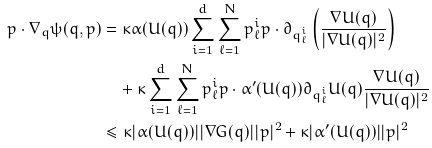Convert formula to latex. <formula><loc_0><loc_0><loc_500><loc_500>p \cdot \nabla _ { q } \psi ( q , p ) & = \kappa \alpha ( U ( q ) ) \sum _ { i = 1 } ^ { d } \sum _ { \ell = 1 } ^ { N } p _ { \ell } ^ { i } p \cdot \partial _ { q _ { \ell } ^ { i } } \left ( \frac { \nabla U ( q ) } { | \nabla U ( q ) | ^ { 2 } } \right ) \\ & \quad + \kappa \sum _ { i = 1 } ^ { d } \sum _ { \ell = 1 } ^ { N } p _ { \ell } ^ { i } p \cdot \alpha ^ { \prime } ( U ( q ) ) \partial _ { q _ { \ell } ^ { i } } U ( q ) \frac { \nabla U ( q ) } { | \nabla U ( q ) | ^ { 2 } } \\ & \leq \kappa | \alpha ( U ( q ) ) | | \nabla G ( q ) | | p | ^ { 2 } + \kappa | \alpha ^ { \prime } ( U ( q ) ) | | p | ^ { 2 }</formula> 